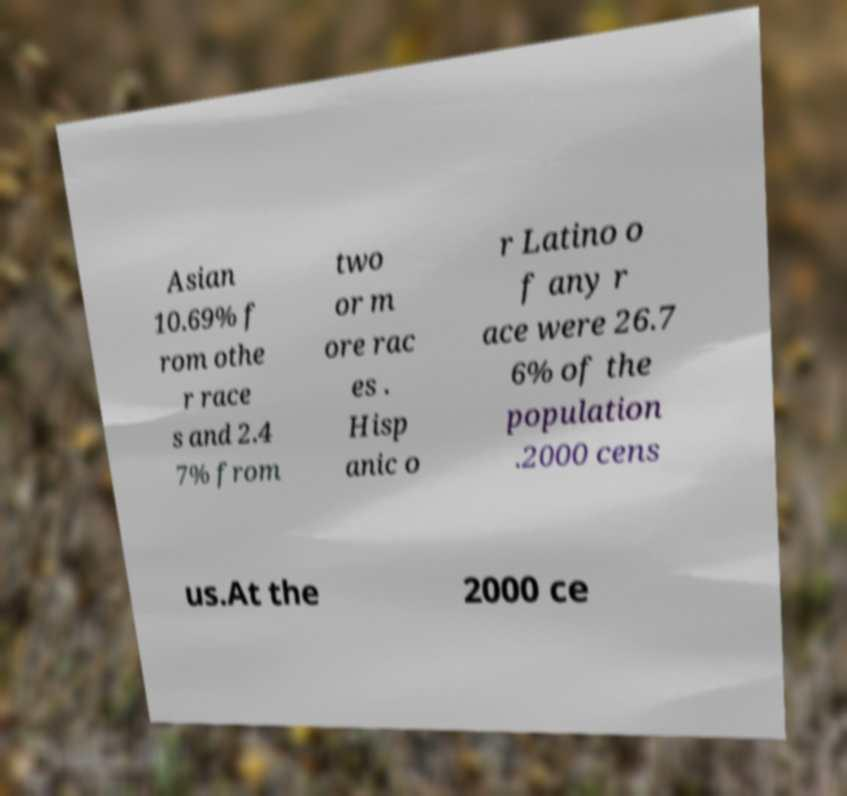There's text embedded in this image that I need extracted. Can you transcribe it verbatim? Asian 10.69% f rom othe r race s and 2.4 7% from two or m ore rac es . Hisp anic o r Latino o f any r ace were 26.7 6% of the population .2000 cens us.At the 2000 ce 